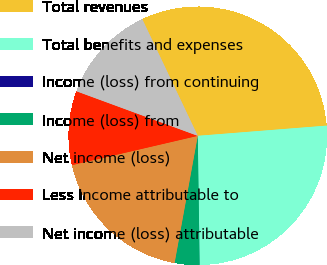<chart> <loc_0><loc_0><loc_500><loc_500><pie_chart><fcel>Total revenues<fcel>Total benefits and expenses<fcel>Income (loss) from continuing<fcel>Income (loss) from<fcel>Net income (loss)<fcel>Less Income attributable to<fcel>Net income (loss) attributable<nl><fcel>30.81%<fcel>26.03%<fcel>0.01%<fcel>3.09%<fcel>18.49%<fcel>9.25%<fcel>12.33%<nl></chart> 